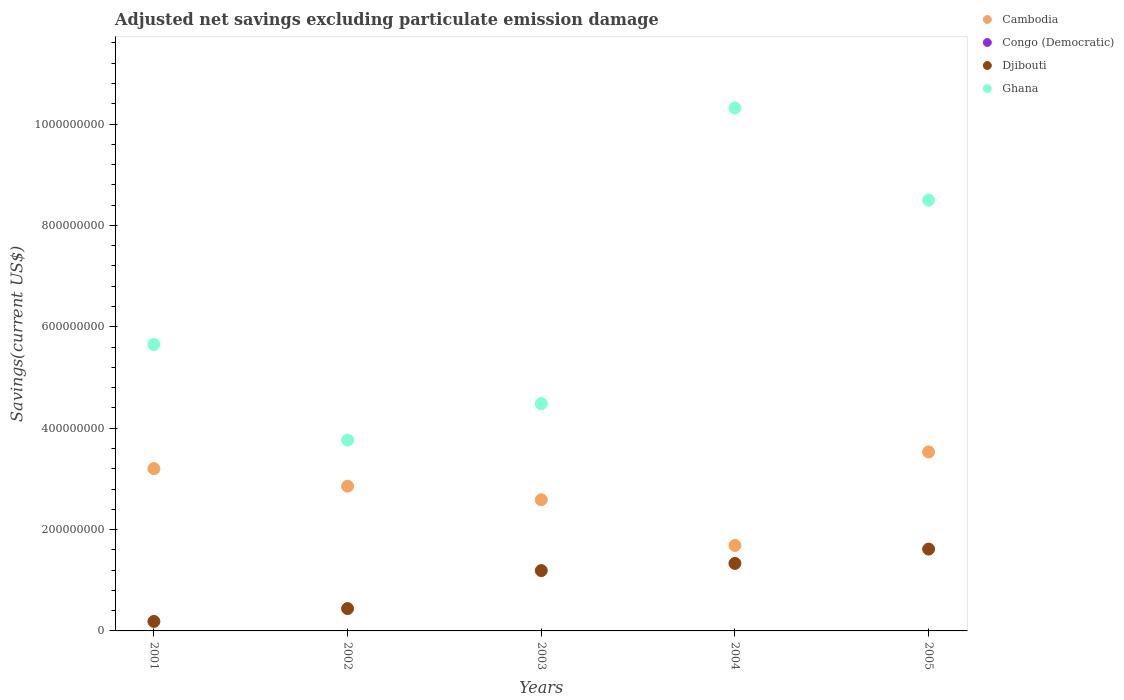Is the number of dotlines equal to the number of legend labels?
Offer a terse response. No. What is the adjusted net savings in Congo (Democratic) in 2001?
Your answer should be compact. 0. Across all years, what is the maximum adjusted net savings in Cambodia?
Offer a terse response. 3.53e+08. Across all years, what is the minimum adjusted net savings in Djibouti?
Make the answer very short. 1.87e+07. In which year was the adjusted net savings in Djibouti maximum?
Give a very brief answer. 2005. What is the total adjusted net savings in Cambodia in the graph?
Your answer should be compact. 1.39e+09. What is the difference between the adjusted net savings in Ghana in 2002 and that in 2004?
Offer a terse response. -6.55e+08. What is the difference between the adjusted net savings in Djibouti in 2004 and the adjusted net savings in Ghana in 2001?
Your answer should be compact. -4.32e+08. What is the average adjusted net savings in Ghana per year?
Offer a very short reply. 6.54e+08. In the year 2002, what is the difference between the adjusted net savings in Cambodia and adjusted net savings in Ghana?
Offer a terse response. -9.09e+07. What is the ratio of the adjusted net savings in Cambodia in 2001 to that in 2002?
Give a very brief answer. 1.12. Is the adjusted net savings in Djibouti in 2004 less than that in 2005?
Give a very brief answer. Yes. What is the difference between the highest and the second highest adjusted net savings in Djibouti?
Keep it short and to the point. 2.83e+07. What is the difference between the highest and the lowest adjusted net savings in Ghana?
Ensure brevity in your answer.  6.55e+08. In how many years, is the adjusted net savings in Congo (Democratic) greater than the average adjusted net savings in Congo (Democratic) taken over all years?
Keep it short and to the point. 0. Is it the case that in every year, the sum of the adjusted net savings in Ghana and adjusted net savings in Congo (Democratic)  is greater than the adjusted net savings in Cambodia?
Give a very brief answer. Yes. Is the adjusted net savings in Djibouti strictly less than the adjusted net savings in Congo (Democratic) over the years?
Your answer should be compact. No. How many dotlines are there?
Provide a short and direct response. 3. How many years are there in the graph?
Give a very brief answer. 5. What is the difference between two consecutive major ticks on the Y-axis?
Offer a terse response. 2.00e+08. Are the values on the major ticks of Y-axis written in scientific E-notation?
Offer a terse response. No. What is the title of the graph?
Offer a very short reply. Adjusted net savings excluding particulate emission damage. What is the label or title of the X-axis?
Keep it short and to the point. Years. What is the label or title of the Y-axis?
Give a very brief answer. Savings(current US$). What is the Savings(current US$) in Cambodia in 2001?
Your answer should be very brief. 3.20e+08. What is the Savings(current US$) of Congo (Democratic) in 2001?
Keep it short and to the point. 0. What is the Savings(current US$) in Djibouti in 2001?
Give a very brief answer. 1.87e+07. What is the Savings(current US$) of Ghana in 2001?
Offer a very short reply. 5.65e+08. What is the Savings(current US$) of Cambodia in 2002?
Offer a very short reply. 2.86e+08. What is the Savings(current US$) in Djibouti in 2002?
Your answer should be compact. 4.41e+07. What is the Savings(current US$) of Ghana in 2002?
Offer a terse response. 3.76e+08. What is the Savings(current US$) of Cambodia in 2003?
Offer a very short reply. 2.59e+08. What is the Savings(current US$) of Congo (Democratic) in 2003?
Provide a short and direct response. 0. What is the Savings(current US$) of Djibouti in 2003?
Your answer should be very brief. 1.19e+08. What is the Savings(current US$) of Ghana in 2003?
Offer a very short reply. 4.48e+08. What is the Savings(current US$) of Cambodia in 2004?
Provide a succinct answer. 1.69e+08. What is the Savings(current US$) in Congo (Democratic) in 2004?
Keep it short and to the point. 0. What is the Savings(current US$) in Djibouti in 2004?
Offer a very short reply. 1.33e+08. What is the Savings(current US$) in Ghana in 2004?
Provide a succinct answer. 1.03e+09. What is the Savings(current US$) in Cambodia in 2005?
Your answer should be compact. 3.53e+08. What is the Savings(current US$) in Djibouti in 2005?
Provide a succinct answer. 1.61e+08. What is the Savings(current US$) of Ghana in 2005?
Your answer should be compact. 8.50e+08. Across all years, what is the maximum Savings(current US$) of Cambodia?
Your answer should be very brief. 3.53e+08. Across all years, what is the maximum Savings(current US$) in Djibouti?
Your answer should be very brief. 1.61e+08. Across all years, what is the maximum Savings(current US$) in Ghana?
Provide a succinct answer. 1.03e+09. Across all years, what is the minimum Savings(current US$) of Cambodia?
Provide a short and direct response. 1.69e+08. Across all years, what is the minimum Savings(current US$) of Djibouti?
Provide a succinct answer. 1.87e+07. Across all years, what is the minimum Savings(current US$) in Ghana?
Ensure brevity in your answer.  3.76e+08. What is the total Savings(current US$) in Cambodia in the graph?
Offer a terse response. 1.39e+09. What is the total Savings(current US$) of Congo (Democratic) in the graph?
Make the answer very short. 0. What is the total Savings(current US$) in Djibouti in the graph?
Your answer should be very brief. 4.76e+08. What is the total Savings(current US$) of Ghana in the graph?
Keep it short and to the point. 3.27e+09. What is the difference between the Savings(current US$) in Cambodia in 2001 and that in 2002?
Make the answer very short. 3.47e+07. What is the difference between the Savings(current US$) of Djibouti in 2001 and that in 2002?
Ensure brevity in your answer.  -2.54e+07. What is the difference between the Savings(current US$) in Ghana in 2001 and that in 2002?
Your answer should be very brief. 1.89e+08. What is the difference between the Savings(current US$) of Cambodia in 2001 and that in 2003?
Your answer should be compact. 6.15e+07. What is the difference between the Savings(current US$) in Djibouti in 2001 and that in 2003?
Your answer should be very brief. -1.00e+08. What is the difference between the Savings(current US$) in Ghana in 2001 and that in 2003?
Ensure brevity in your answer.  1.17e+08. What is the difference between the Savings(current US$) of Cambodia in 2001 and that in 2004?
Provide a short and direct response. 1.52e+08. What is the difference between the Savings(current US$) in Djibouti in 2001 and that in 2004?
Offer a very short reply. -1.14e+08. What is the difference between the Savings(current US$) in Ghana in 2001 and that in 2004?
Ensure brevity in your answer.  -4.67e+08. What is the difference between the Savings(current US$) of Cambodia in 2001 and that in 2005?
Your response must be concise. -3.28e+07. What is the difference between the Savings(current US$) of Djibouti in 2001 and that in 2005?
Offer a very short reply. -1.43e+08. What is the difference between the Savings(current US$) in Ghana in 2001 and that in 2005?
Make the answer very short. -2.85e+08. What is the difference between the Savings(current US$) of Cambodia in 2002 and that in 2003?
Your response must be concise. 2.68e+07. What is the difference between the Savings(current US$) in Djibouti in 2002 and that in 2003?
Make the answer very short. -7.50e+07. What is the difference between the Savings(current US$) of Ghana in 2002 and that in 2003?
Keep it short and to the point. -7.19e+07. What is the difference between the Savings(current US$) of Cambodia in 2002 and that in 2004?
Give a very brief answer. 1.17e+08. What is the difference between the Savings(current US$) of Djibouti in 2002 and that in 2004?
Provide a succinct answer. -8.91e+07. What is the difference between the Savings(current US$) in Ghana in 2002 and that in 2004?
Provide a succinct answer. -6.55e+08. What is the difference between the Savings(current US$) in Cambodia in 2002 and that in 2005?
Keep it short and to the point. -6.75e+07. What is the difference between the Savings(current US$) of Djibouti in 2002 and that in 2005?
Give a very brief answer. -1.17e+08. What is the difference between the Savings(current US$) in Ghana in 2002 and that in 2005?
Provide a succinct answer. -4.73e+08. What is the difference between the Savings(current US$) of Cambodia in 2003 and that in 2004?
Keep it short and to the point. 9.01e+07. What is the difference between the Savings(current US$) in Djibouti in 2003 and that in 2004?
Give a very brief answer. -1.41e+07. What is the difference between the Savings(current US$) of Ghana in 2003 and that in 2004?
Offer a terse response. -5.83e+08. What is the difference between the Savings(current US$) in Cambodia in 2003 and that in 2005?
Your answer should be compact. -9.43e+07. What is the difference between the Savings(current US$) of Djibouti in 2003 and that in 2005?
Your answer should be very brief. -4.24e+07. What is the difference between the Savings(current US$) in Ghana in 2003 and that in 2005?
Provide a succinct answer. -4.02e+08. What is the difference between the Savings(current US$) in Cambodia in 2004 and that in 2005?
Your answer should be compact. -1.84e+08. What is the difference between the Savings(current US$) in Djibouti in 2004 and that in 2005?
Ensure brevity in your answer.  -2.83e+07. What is the difference between the Savings(current US$) of Ghana in 2004 and that in 2005?
Your answer should be very brief. 1.82e+08. What is the difference between the Savings(current US$) in Cambodia in 2001 and the Savings(current US$) in Djibouti in 2002?
Offer a terse response. 2.76e+08. What is the difference between the Savings(current US$) of Cambodia in 2001 and the Savings(current US$) of Ghana in 2002?
Keep it short and to the point. -5.62e+07. What is the difference between the Savings(current US$) in Djibouti in 2001 and the Savings(current US$) in Ghana in 2002?
Your answer should be very brief. -3.58e+08. What is the difference between the Savings(current US$) of Cambodia in 2001 and the Savings(current US$) of Djibouti in 2003?
Ensure brevity in your answer.  2.01e+08. What is the difference between the Savings(current US$) of Cambodia in 2001 and the Savings(current US$) of Ghana in 2003?
Offer a terse response. -1.28e+08. What is the difference between the Savings(current US$) in Djibouti in 2001 and the Savings(current US$) in Ghana in 2003?
Give a very brief answer. -4.30e+08. What is the difference between the Savings(current US$) of Cambodia in 2001 and the Savings(current US$) of Djibouti in 2004?
Your answer should be very brief. 1.87e+08. What is the difference between the Savings(current US$) of Cambodia in 2001 and the Savings(current US$) of Ghana in 2004?
Your answer should be compact. -7.11e+08. What is the difference between the Savings(current US$) in Djibouti in 2001 and the Savings(current US$) in Ghana in 2004?
Your response must be concise. -1.01e+09. What is the difference between the Savings(current US$) in Cambodia in 2001 and the Savings(current US$) in Djibouti in 2005?
Offer a terse response. 1.59e+08. What is the difference between the Savings(current US$) of Cambodia in 2001 and the Savings(current US$) of Ghana in 2005?
Ensure brevity in your answer.  -5.30e+08. What is the difference between the Savings(current US$) in Djibouti in 2001 and the Savings(current US$) in Ghana in 2005?
Keep it short and to the point. -8.31e+08. What is the difference between the Savings(current US$) of Cambodia in 2002 and the Savings(current US$) of Djibouti in 2003?
Give a very brief answer. 1.67e+08. What is the difference between the Savings(current US$) of Cambodia in 2002 and the Savings(current US$) of Ghana in 2003?
Make the answer very short. -1.63e+08. What is the difference between the Savings(current US$) of Djibouti in 2002 and the Savings(current US$) of Ghana in 2003?
Provide a short and direct response. -4.04e+08. What is the difference between the Savings(current US$) in Cambodia in 2002 and the Savings(current US$) in Djibouti in 2004?
Your response must be concise. 1.52e+08. What is the difference between the Savings(current US$) of Cambodia in 2002 and the Savings(current US$) of Ghana in 2004?
Your answer should be very brief. -7.46e+08. What is the difference between the Savings(current US$) of Djibouti in 2002 and the Savings(current US$) of Ghana in 2004?
Your response must be concise. -9.88e+08. What is the difference between the Savings(current US$) of Cambodia in 2002 and the Savings(current US$) of Djibouti in 2005?
Offer a terse response. 1.24e+08. What is the difference between the Savings(current US$) in Cambodia in 2002 and the Savings(current US$) in Ghana in 2005?
Keep it short and to the point. -5.64e+08. What is the difference between the Savings(current US$) in Djibouti in 2002 and the Savings(current US$) in Ghana in 2005?
Provide a succinct answer. -8.06e+08. What is the difference between the Savings(current US$) of Cambodia in 2003 and the Savings(current US$) of Djibouti in 2004?
Give a very brief answer. 1.26e+08. What is the difference between the Savings(current US$) in Cambodia in 2003 and the Savings(current US$) in Ghana in 2004?
Offer a very short reply. -7.73e+08. What is the difference between the Savings(current US$) in Djibouti in 2003 and the Savings(current US$) in Ghana in 2004?
Your answer should be compact. -9.13e+08. What is the difference between the Savings(current US$) in Cambodia in 2003 and the Savings(current US$) in Djibouti in 2005?
Ensure brevity in your answer.  9.73e+07. What is the difference between the Savings(current US$) of Cambodia in 2003 and the Savings(current US$) of Ghana in 2005?
Make the answer very short. -5.91e+08. What is the difference between the Savings(current US$) in Djibouti in 2003 and the Savings(current US$) in Ghana in 2005?
Your answer should be very brief. -7.31e+08. What is the difference between the Savings(current US$) of Cambodia in 2004 and the Savings(current US$) of Djibouti in 2005?
Provide a succinct answer. 7.18e+06. What is the difference between the Savings(current US$) of Cambodia in 2004 and the Savings(current US$) of Ghana in 2005?
Make the answer very short. -6.81e+08. What is the difference between the Savings(current US$) in Djibouti in 2004 and the Savings(current US$) in Ghana in 2005?
Ensure brevity in your answer.  -7.17e+08. What is the average Savings(current US$) in Cambodia per year?
Your answer should be very brief. 2.77e+08. What is the average Savings(current US$) of Djibouti per year?
Your response must be concise. 9.53e+07. What is the average Savings(current US$) of Ghana per year?
Ensure brevity in your answer.  6.54e+08. In the year 2001, what is the difference between the Savings(current US$) of Cambodia and Savings(current US$) of Djibouti?
Provide a short and direct response. 3.02e+08. In the year 2001, what is the difference between the Savings(current US$) of Cambodia and Savings(current US$) of Ghana?
Ensure brevity in your answer.  -2.45e+08. In the year 2001, what is the difference between the Savings(current US$) of Djibouti and Savings(current US$) of Ghana?
Offer a terse response. -5.46e+08. In the year 2002, what is the difference between the Savings(current US$) of Cambodia and Savings(current US$) of Djibouti?
Provide a short and direct response. 2.42e+08. In the year 2002, what is the difference between the Savings(current US$) in Cambodia and Savings(current US$) in Ghana?
Your answer should be very brief. -9.09e+07. In the year 2002, what is the difference between the Savings(current US$) of Djibouti and Savings(current US$) of Ghana?
Your answer should be compact. -3.32e+08. In the year 2003, what is the difference between the Savings(current US$) of Cambodia and Savings(current US$) of Djibouti?
Give a very brief answer. 1.40e+08. In the year 2003, what is the difference between the Savings(current US$) in Cambodia and Savings(current US$) in Ghana?
Your answer should be compact. -1.90e+08. In the year 2003, what is the difference between the Savings(current US$) in Djibouti and Savings(current US$) in Ghana?
Your response must be concise. -3.29e+08. In the year 2004, what is the difference between the Savings(current US$) in Cambodia and Savings(current US$) in Djibouti?
Your response must be concise. 3.55e+07. In the year 2004, what is the difference between the Savings(current US$) in Cambodia and Savings(current US$) in Ghana?
Your answer should be very brief. -8.63e+08. In the year 2004, what is the difference between the Savings(current US$) of Djibouti and Savings(current US$) of Ghana?
Your answer should be compact. -8.99e+08. In the year 2005, what is the difference between the Savings(current US$) of Cambodia and Savings(current US$) of Djibouti?
Keep it short and to the point. 1.92e+08. In the year 2005, what is the difference between the Savings(current US$) of Cambodia and Savings(current US$) of Ghana?
Give a very brief answer. -4.97e+08. In the year 2005, what is the difference between the Savings(current US$) of Djibouti and Savings(current US$) of Ghana?
Ensure brevity in your answer.  -6.89e+08. What is the ratio of the Savings(current US$) of Cambodia in 2001 to that in 2002?
Provide a short and direct response. 1.12. What is the ratio of the Savings(current US$) in Djibouti in 2001 to that in 2002?
Make the answer very short. 0.42. What is the ratio of the Savings(current US$) in Ghana in 2001 to that in 2002?
Make the answer very short. 1.5. What is the ratio of the Savings(current US$) in Cambodia in 2001 to that in 2003?
Offer a terse response. 1.24. What is the ratio of the Savings(current US$) of Djibouti in 2001 to that in 2003?
Make the answer very short. 0.16. What is the ratio of the Savings(current US$) in Ghana in 2001 to that in 2003?
Offer a terse response. 1.26. What is the ratio of the Savings(current US$) in Cambodia in 2001 to that in 2004?
Your answer should be very brief. 1.9. What is the ratio of the Savings(current US$) of Djibouti in 2001 to that in 2004?
Your response must be concise. 0.14. What is the ratio of the Savings(current US$) in Ghana in 2001 to that in 2004?
Offer a very short reply. 0.55. What is the ratio of the Savings(current US$) of Cambodia in 2001 to that in 2005?
Provide a short and direct response. 0.91. What is the ratio of the Savings(current US$) of Djibouti in 2001 to that in 2005?
Give a very brief answer. 0.12. What is the ratio of the Savings(current US$) of Ghana in 2001 to that in 2005?
Your answer should be compact. 0.66. What is the ratio of the Savings(current US$) of Cambodia in 2002 to that in 2003?
Offer a very short reply. 1.1. What is the ratio of the Savings(current US$) of Djibouti in 2002 to that in 2003?
Offer a terse response. 0.37. What is the ratio of the Savings(current US$) in Ghana in 2002 to that in 2003?
Your answer should be compact. 0.84. What is the ratio of the Savings(current US$) in Cambodia in 2002 to that in 2004?
Provide a succinct answer. 1.69. What is the ratio of the Savings(current US$) of Djibouti in 2002 to that in 2004?
Your answer should be compact. 0.33. What is the ratio of the Savings(current US$) in Ghana in 2002 to that in 2004?
Your answer should be compact. 0.36. What is the ratio of the Savings(current US$) of Cambodia in 2002 to that in 2005?
Provide a succinct answer. 0.81. What is the ratio of the Savings(current US$) of Djibouti in 2002 to that in 2005?
Your response must be concise. 0.27. What is the ratio of the Savings(current US$) of Ghana in 2002 to that in 2005?
Your answer should be very brief. 0.44. What is the ratio of the Savings(current US$) in Cambodia in 2003 to that in 2004?
Your response must be concise. 1.53. What is the ratio of the Savings(current US$) in Djibouti in 2003 to that in 2004?
Your response must be concise. 0.89. What is the ratio of the Savings(current US$) of Ghana in 2003 to that in 2004?
Your response must be concise. 0.43. What is the ratio of the Savings(current US$) of Cambodia in 2003 to that in 2005?
Your answer should be compact. 0.73. What is the ratio of the Savings(current US$) in Djibouti in 2003 to that in 2005?
Provide a short and direct response. 0.74. What is the ratio of the Savings(current US$) in Ghana in 2003 to that in 2005?
Give a very brief answer. 0.53. What is the ratio of the Savings(current US$) in Cambodia in 2004 to that in 2005?
Provide a succinct answer. 0.48. What is the ratio of the Savings(current US$) in Djibouti in 2004 to that in 2005?
Offer a very short reply. 0.82. What is the ratio of the Savings(current US$) in Ghana in 2004 to that in 2005?
Your answer should be very brief. 1.21. What is the difference between the highest and the second highest Savings(current US$) in Cambodia?
Ensure brevity in your answer.  3.28e+07. What is the difference between the highest and the second highest Savings(current US$) of Djibouti?
Your response must be concise. 2.83e+07. What is the difference between the highest and the second highest Savings(current US$) of Ghana?
Keep it short and to the point. 1.82e+08. What is the difference between the highest and the lowest Savings(current US$) of Cambodia?
Your response must be concise. 1.84e+08. What is the difference between the highest and the lowest Savings(current US$) in Djibouti?
Offer a very short reply. 1.43e+08. What is the difference between the highest and the lowest Savings(current US$) of Ghana?
Give a very brief answer. 6.55e+08. 